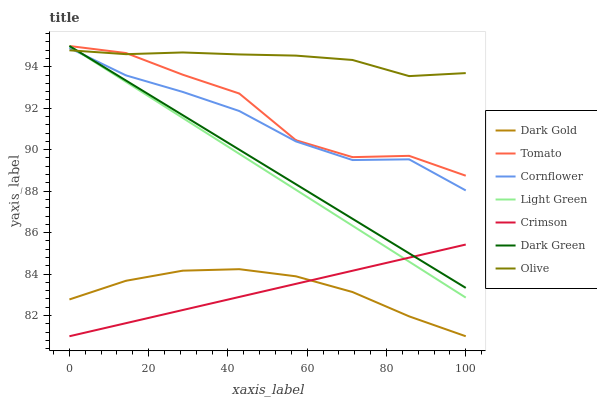Does Crimson have the minimum area under the curve?
Answer yes or no. Yes. Does Olive have the maximum area under the curve?
Answer yes or no. Yes. Does Cornflower have the minimum area under the curve?
Answer yes or no. No. Does Cornflower have the maximum area under the curve?
Answer yes or no. No. Is Light Green the smoothest?
Answer yes or no. Yes. Is Tomato the roughest?
Answer yes or no. Yes. Is Cornflower the smoothest?
Answer yes or no. No. Is Cornflower the roughest?
Answer yes or no. No. Does Dark Gold have the lowest value?
Answer yes or no. Yes. Does Cornflower have the lowest value?
Answer yes or no. No. Does Dark Green have the highest value?
Answer yes or no. Yes. Does Cornflower have the highest value?
Answer yes or no. No. Is Crimson less than Cornflower?
Answer yes or no. Yes. Is Dark Green greater than Dark Gold?
Answer yes or no. Yes. Does Cornflower intersect Olive?
Answer yes or no. Yes. Is Cornflower less than Olive?
Answer yes or no. No. Is Cornflower greater than Olive?
Answer yes or no. No. Does Crimson intersect Cornflower?
Answer yes or no. No. 